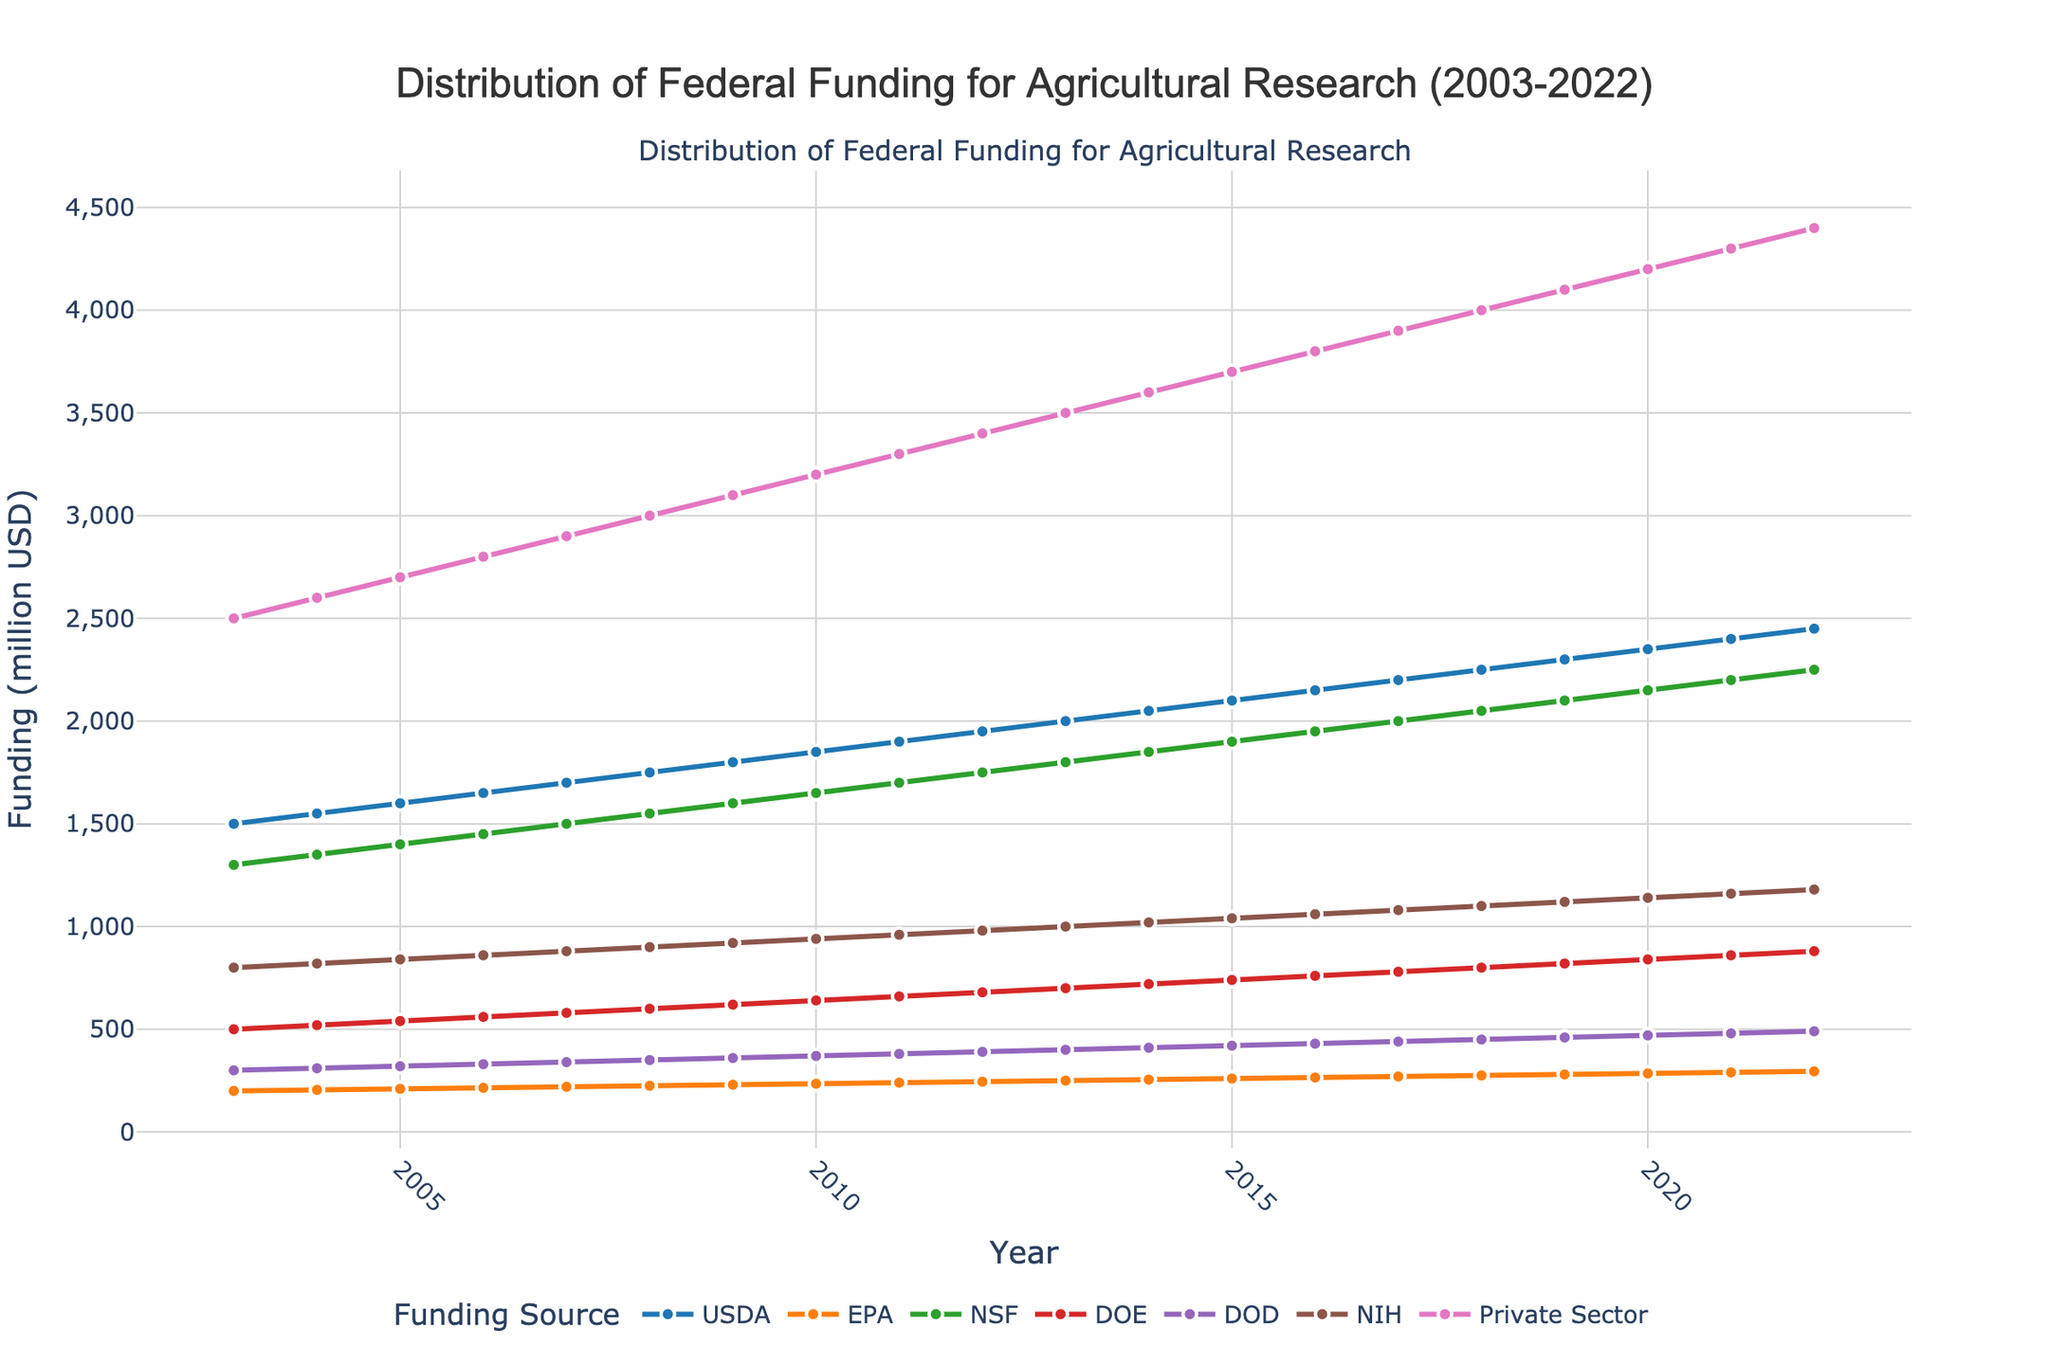What is the title of the plot? The title of the plot is displayed at the top center of the plot. It states "Distribution of Federal Funding for Agricultural Research (2003-2022)" which indicates the plot tracks funding distribution over time.
Answer: Distribution of Federal Funding for Agricultural Research (2003-2022) What are the axes labeled with? The x-axis is labeled "Year," and the y-axis is labeled "Funding (million USD)." This information can be found directly on the plot where the axes titles are displayed.
Answer: Year (x-axis), Funding (million USD) (y-axis) Which funding source had the highest funding in 2022? To determine which funding source had the highest funding in 2022, observe the value at 2022 for each series in the plot. The Private Sector has the highest value at 4400 million USD.
Answer: Private Sector In which year did NIH funding surpass 1000 million USD? Identify the data point where the NIH funding surpasses 1000 million USD and observe the corresponding year on the x-axis. NIH funding reaches 1020 million USD in the year 2014.
Answer: 2014 What is the total funding from USDA and NSF in the year 2010? Sum the USDA and NSF values for the year 2010. The USDA value is 1850 million USD and the NSF value is 1650 million USD, giving a total of 1850 + 1650 = 3500 million USD.
Answer: 3500 million USD Which funding source had the smallest increase in funding from 2003 to 2022? Calculate the difference between the 2022 and 2003 values for each funding source and identify the smallest difference. EPA funding increases from 200 million USD in 2003 to 295 million USD in 2022, the smallest increase of 95 million USD.
Answer: EPA Between which two consecutive years did DOE funding have the highest increase? Calculate the difference for DOE funding between consecutive years and identify the highest increase. The highest increase occurred between 2019 (820 million USD) and 2020 (840 million USD) with a difference of 20 million USD.
Answer: 2019 to 2020 Which funding source showed a consistent increase each year without any decline? Check all series and determine if each year-on-year value increases. Comparing all sources, USDA shows a consistent increasing trend every year from 1500 million USD in 2003 to 2450 million USD in 2022.
Answer: USDA In the year 2015, how much more funding did the Private Sector provide compared to NIH? Observe the values for Private Sector and NIH in 2015. The Private Sector funding is 3700 million USD while NIH is 1040 million USD, giving a difference of 3700 - 1040 = 2660 million USD.
Answer: 2660 million USD What was the average funding by the DOD over the 20-year period? Sum the annual DOD funding values and divide by 20 (number of years). Total DOD funding is 300+310+320+330+340+350+360+370+380+390+400+410+420+430+440+450+460+470+480+490=8380 million USD, so the average is 8380/20 = 419 million USD.
Answer: 419 million USD 